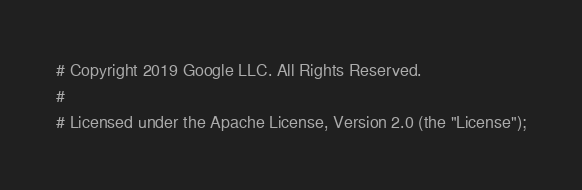Convert code to text. <code><loc_0><loc_0><loc_500><loc_500><_Python_># Copyright 2019 Google LLC. All Rights Reserved.
#
# Licensed under the Apache License, Version 2.0 (the "License");</code> 